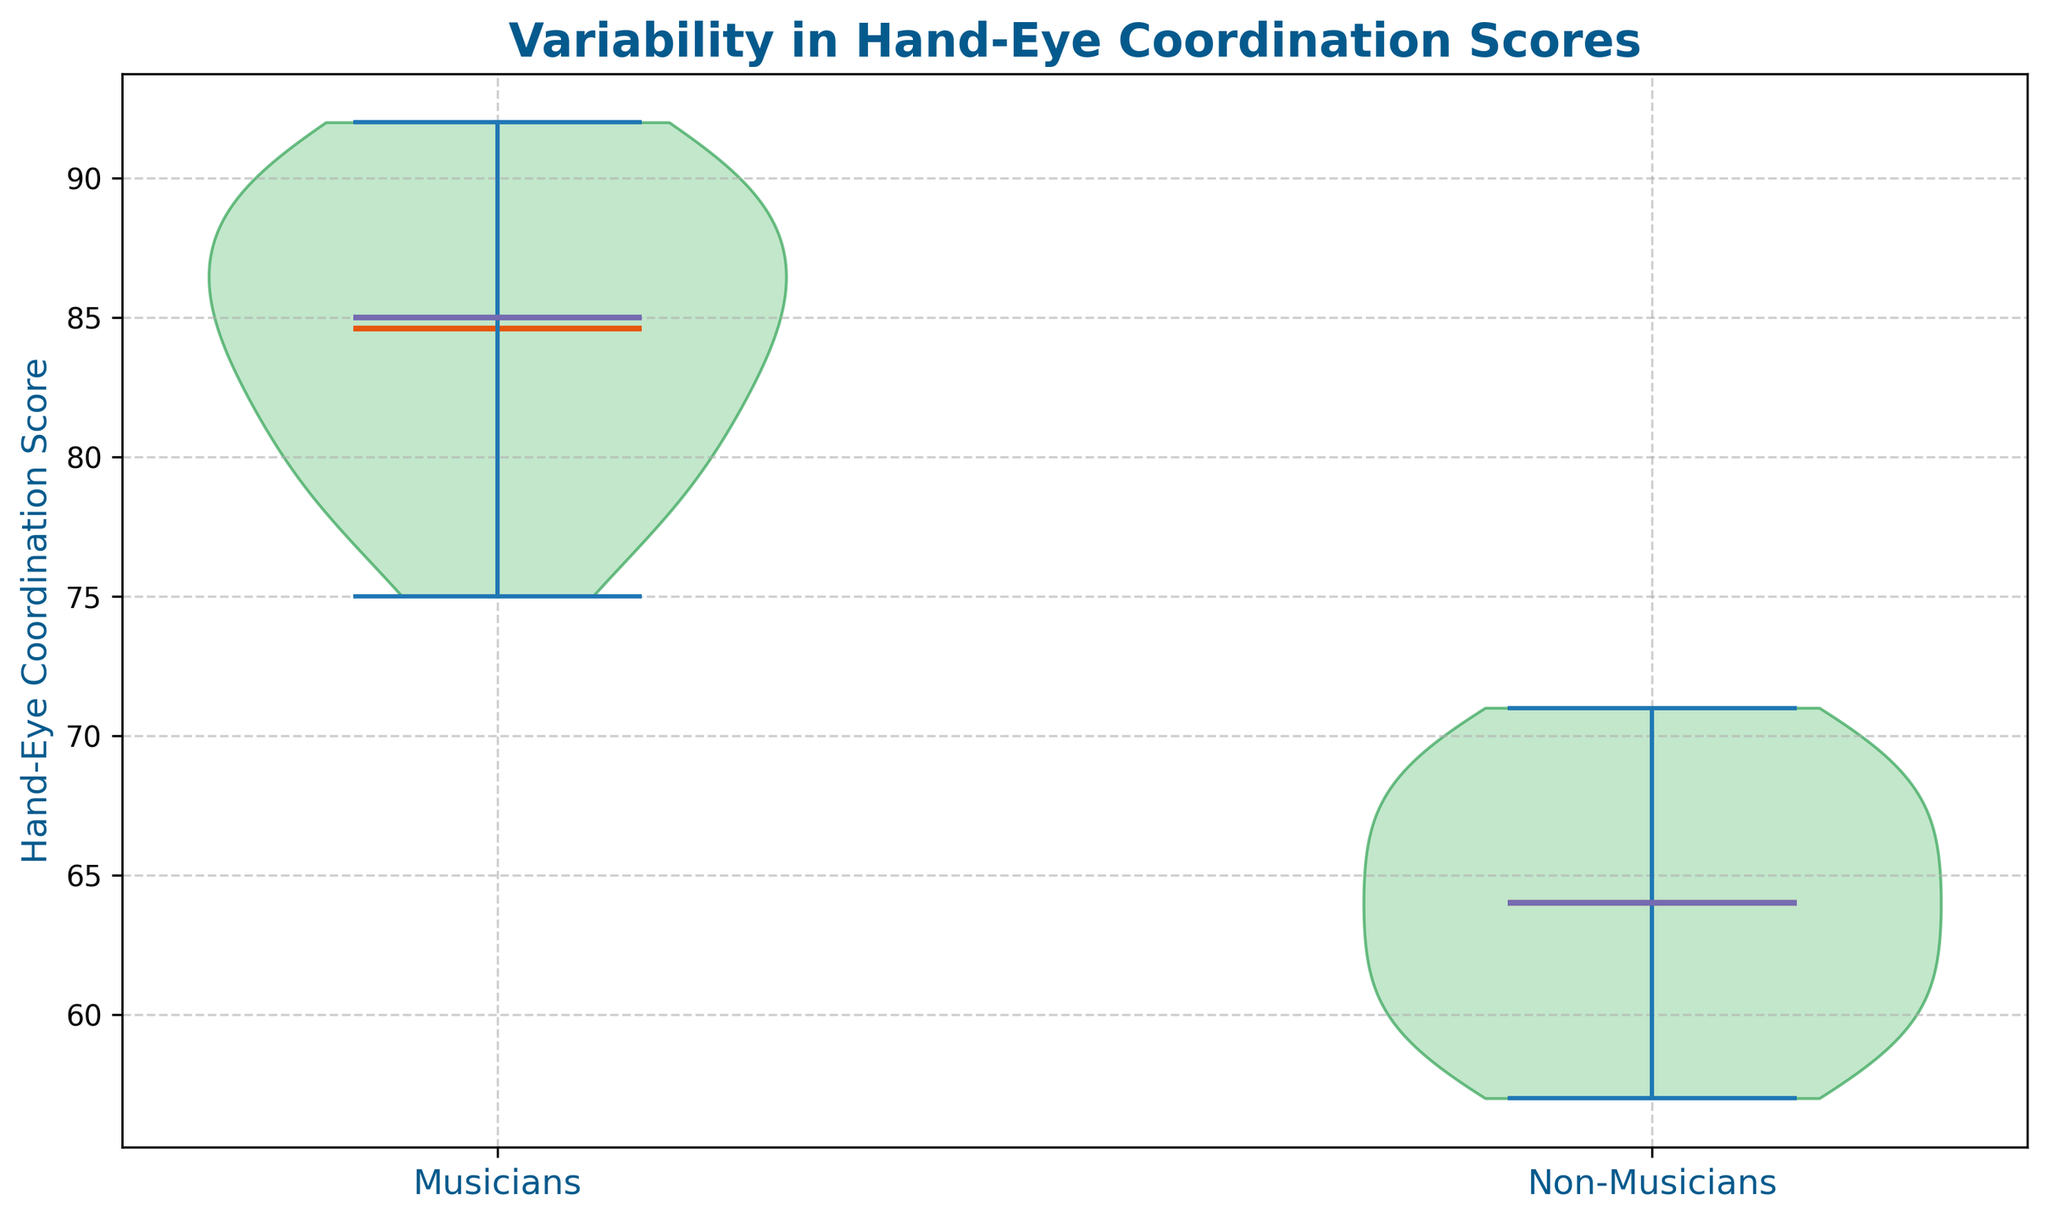Which group's hand-eye coordination scores have greater variability? By examining the spread of scores in the violin plot, we can see that the range and spread of scores for musicians are wider than for non-musicians, indicating greater variability.
Answer: Musicians What is the median hand-eye coordination score for musicians? The median score for musicians can be identified by the central line within the violin plot for the musician group. This line is marked in a distinct color.
Answer: 86 How do the mean scores compare between musicians and non-musicians? The mean scores are represented by a different marker on each violin plot. The average height of these markers indicates that musicians have a higher mean score compared to non-musicians.
Answer: Musicians have a higher mean score Which group has the highest recorded hand-eye coordination score? The highest recorded scores are at the topmost points of the violin plots. The musician group has values reaching up to 92, which is higher than the non-musician group's maximum of 71.
Answer: Musicians What's the range of hand-eye coordination scores for non-musicians? The range is calculated by subtracting the lowest score from the highest score. The violin plot for non-musicians shows scores spanning from roughly 57 to 71. So, (71 - 57) = 14.
Answer: 14 Are there any visible outliers in either group? By inspecting the plot, we can look for any individual points that are separate from the bulk of the distribution. In this particular plot, no distinct outliers are visually separated from the distributions of either group.
Answer: No How do the interquartile ranges (IQR) compare between musicians and non-musicians? The IQR can be approximated by the range between the outer edges of the box-like middle section of each violin plot. Musicians exhibit a broader IQR compared to non-musicians, indicating more variability within the middle 50% of their scores.
Answer: Musicians have a broader IQR Describe the symmetry of the distributions for both groups. By looking at the shape of the violin plots, we can describe the symmetry. The distribution for musicians is relatively symmetric, while the non-musician distribution appears slightly skewed, with a longer tail toward lower scores.
Answer: Musicians are symmetric, Non-musicians are skewed What does the central tendency of hand-eye coordination scores for non-musicians indicate? The central line in the non-musician plot shows a median score, and this along with the distribution shape suggests a central tendency skewed lower than that of musicians, indicating overall lower central scores.
Answer: Lower central scores 